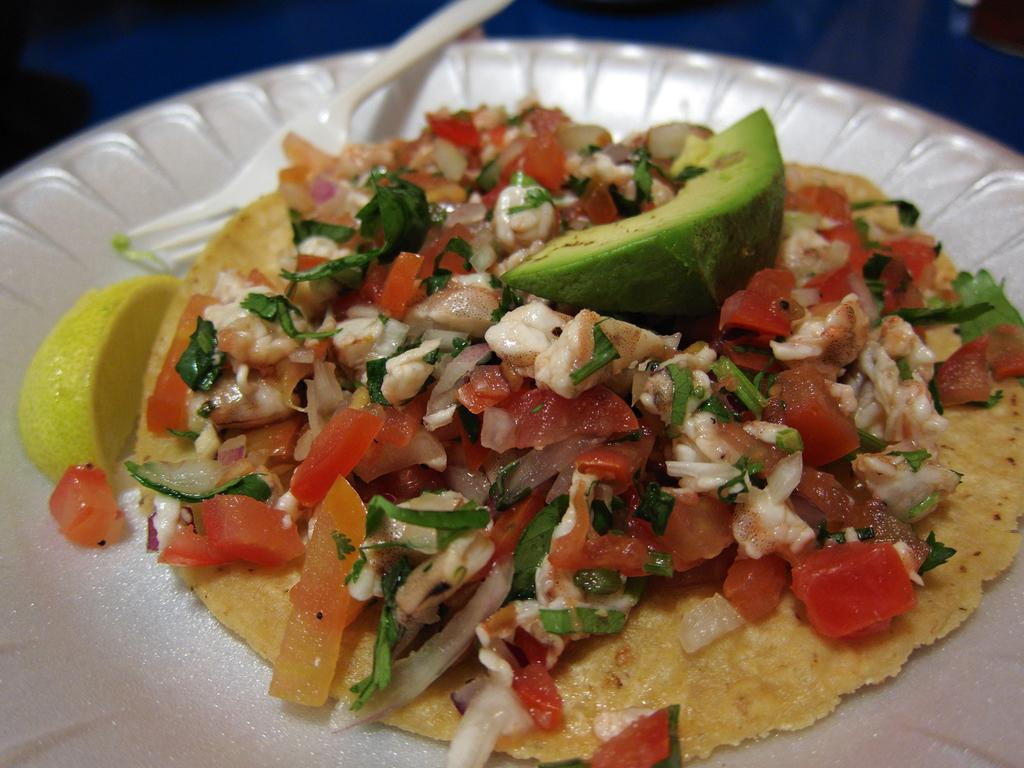What is the color of the plate in the image? The plate in the image is white. What is on the plate? There is food on the plate. Can you describe the colors of the food? The food has white, green, red, and cream colors. What is a specific ingredient visible in the food? There is a piece of lemon in the food. What utensil is present on the plate? There is a fork on the plate. What verse is being recited by the kitty in the image? There is no kitty present in the image, and therefore no verse being recited. 